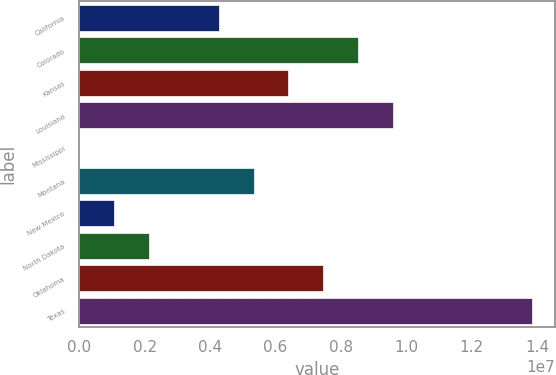Convert chart to OTSL. <chart><loc_0><loc_0><loc_500><loc_500><bar_chart><fcel>California<fcel>Colorado<fcel>Kansas<fcel>Louisiana<fcel>Mississippi<fcel>Montana<fcel>New Mexico<fcel>North Dakota<fcel>Oklahoma<fcel>Texas<nl><fcel>4.26439e+06<fcel>8.5269e+06<fcel>6.39564e+06<fcel>9.59252e+06<fcel>1884<fcel>5.33002e+06<fcel>1.06751e+06<fcel>2.13314e+06<fcel>7.46127e+06<fcel>1.3855e+07<nl></chart> 